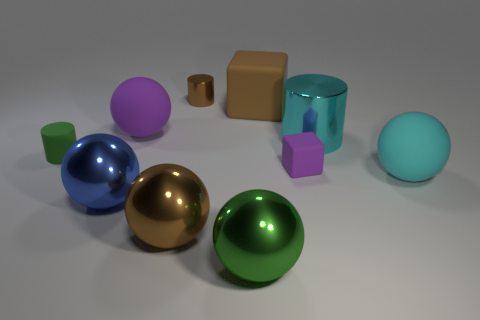Subtract all brown balls. How many balls are left? 4 Subtract all purple spheres. How many spheres are left? 4 Subtract all yellow balls. Subtract all green cylinders. How many balls are left? 5 Subtract all cylinders. How many objects are left? 7 Add 1 big gray metal blocks. How many big gray metal blocks exist? 1 Subtract 1 purple balls. How many objects are left? 9 Subtract all big green metal blocks. Subtract all small purple things. How many objects are left? 9 Add 7 green rubber cylinders. How many green rubber cylinders are left? 8 